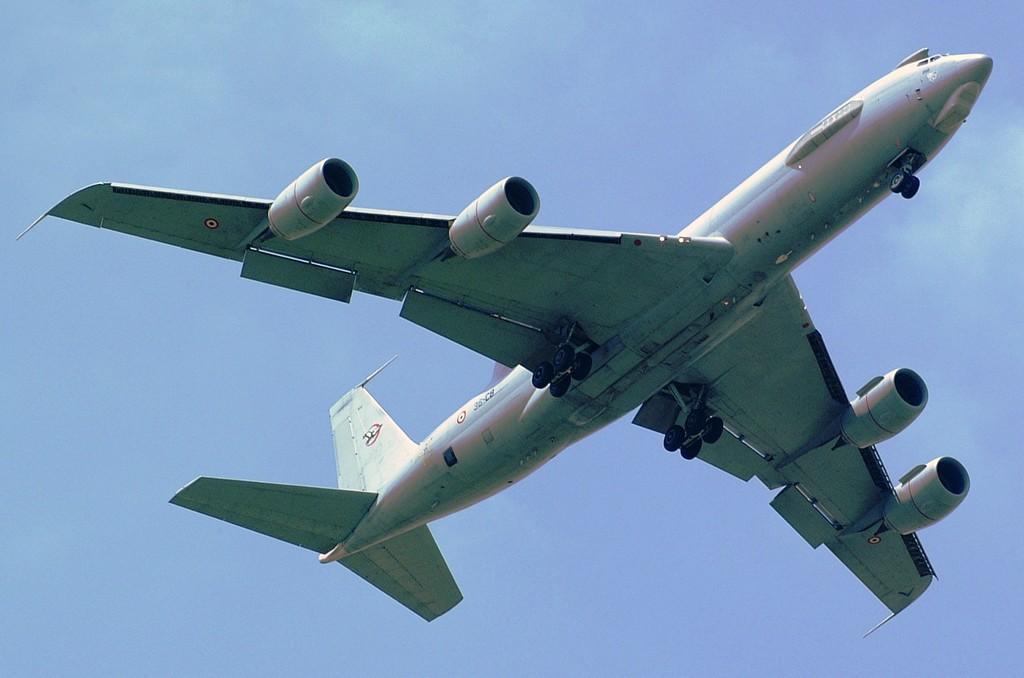How would you summarize this image in a sentence or two? Here we can see an aeroplane flying in the sky. 